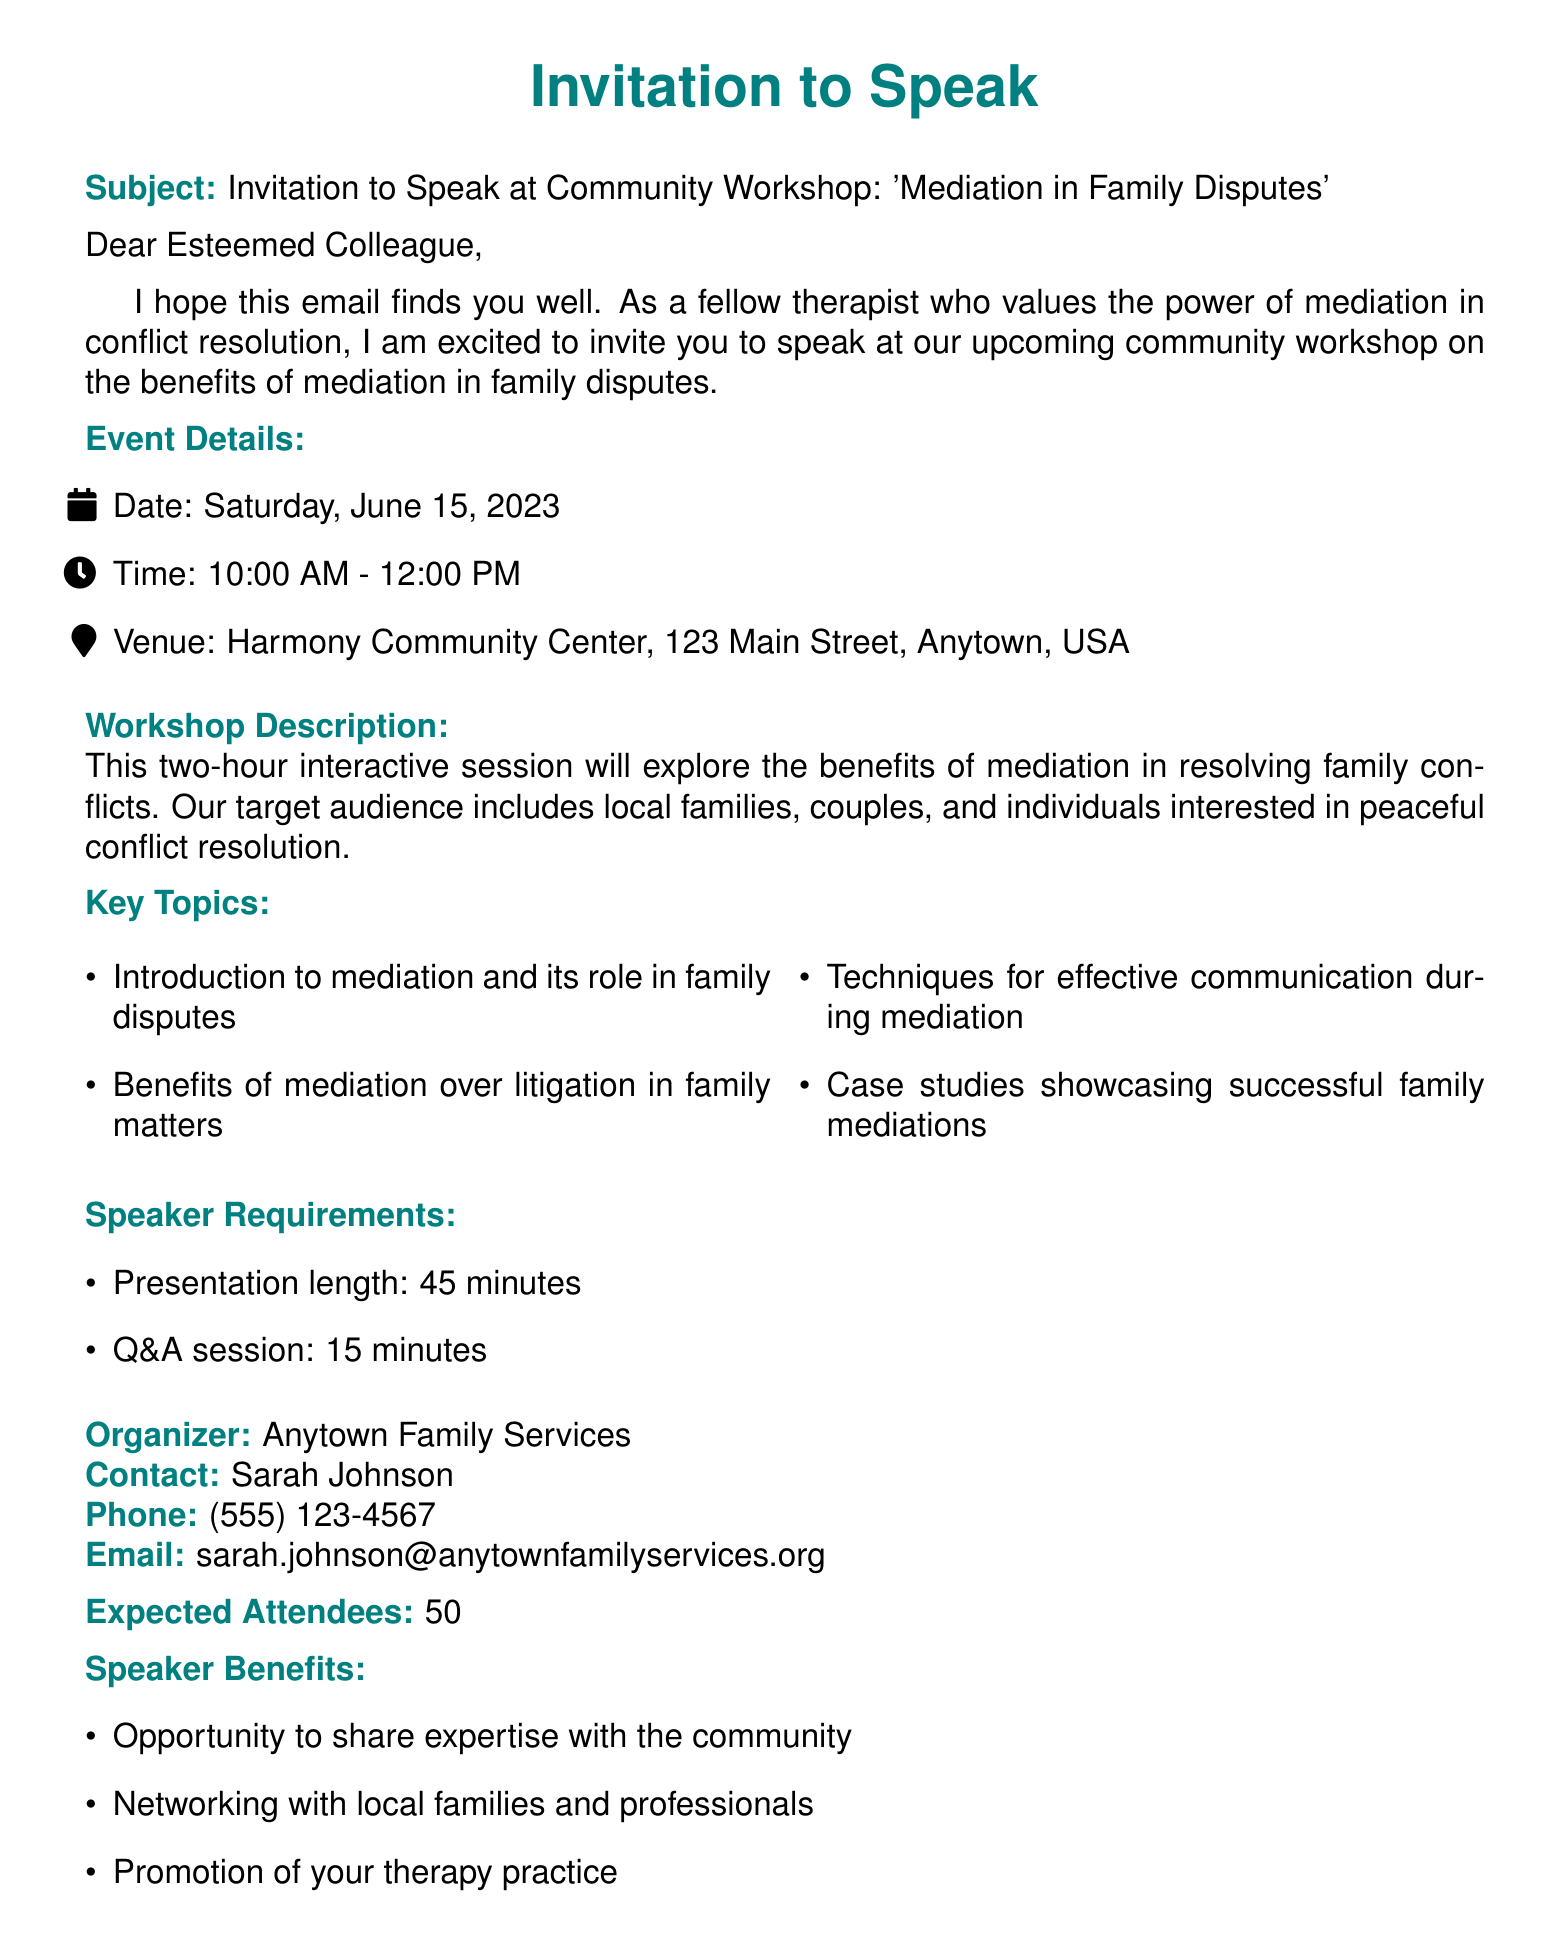What is the date of the workshop? The date of the workshop is clearly stated in the event details section of the document.
Answer: Saturday, June 15, 2023 What is the duration of the workshop? The document mentions that the workshop is a two-hour interactive session.
Answer: Two hours Who is the contact person for the event? The organizer's section lists the contact person responsible for the event.
Answer: Sarah Johnson What time does the workshop start? The starting time of the workshop is provided under event details.
Answer: 10:00 AM What are the expected attendees? The document specifies the number of expected attendees as part of the event details.
Answer: 50 What is the presentation length for the speaker? The speaker requirements section includes information about the required presentation duration.
Answer: 45 minutes What is one benefit of being a speaker at this workshop? The document lists several benefits of speaking, which can be found in the speaker benefits section.
Answer: Opportunity to share expertise with the community What is the email address to confirm attendance? The contact section provides the email address for the organizer for confirmation.
Answer: sarah.johnson@anytownfamilyservices.org What is the venue for the workshop? The venue is clearly stated in the event details section of the document.
Answer: Harmony Community Center, 123 Main Street, Anytown, USA 